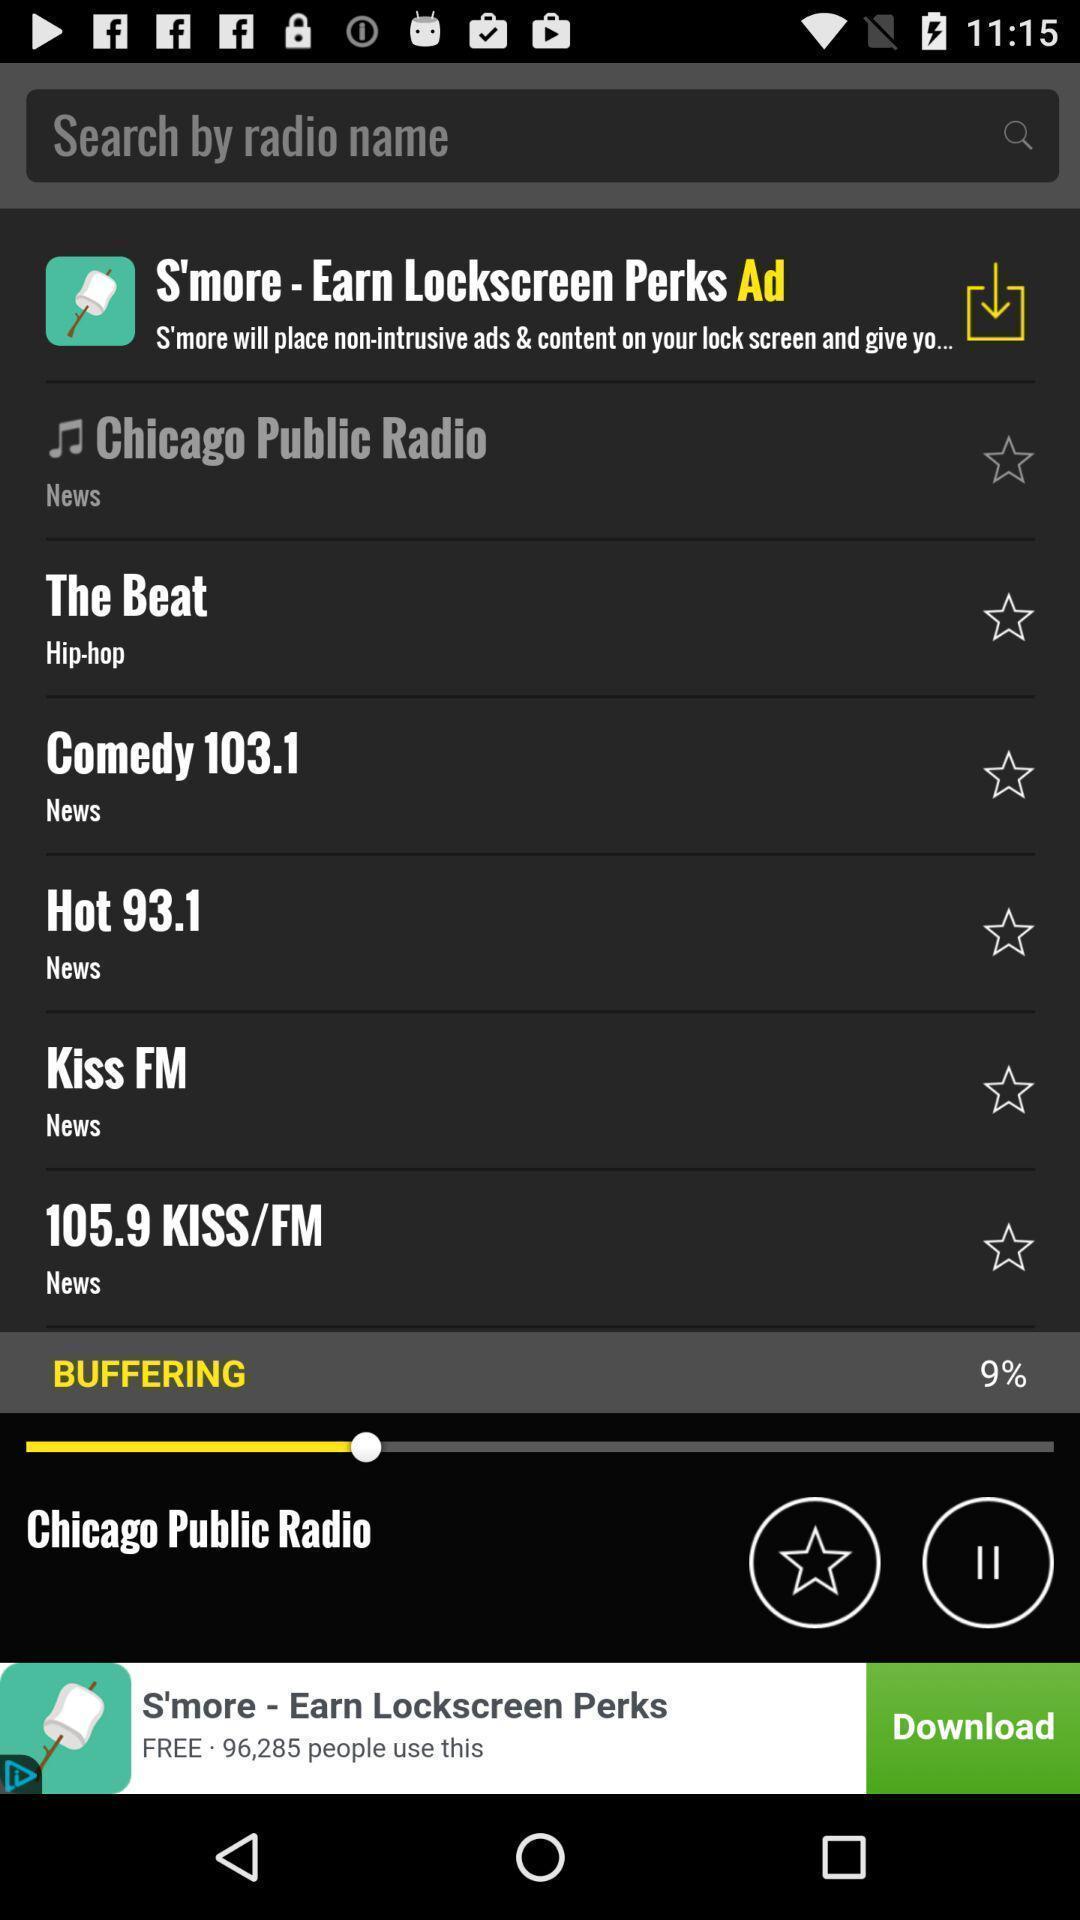What can you discern from this picture? Page showing features from a monetary app. 